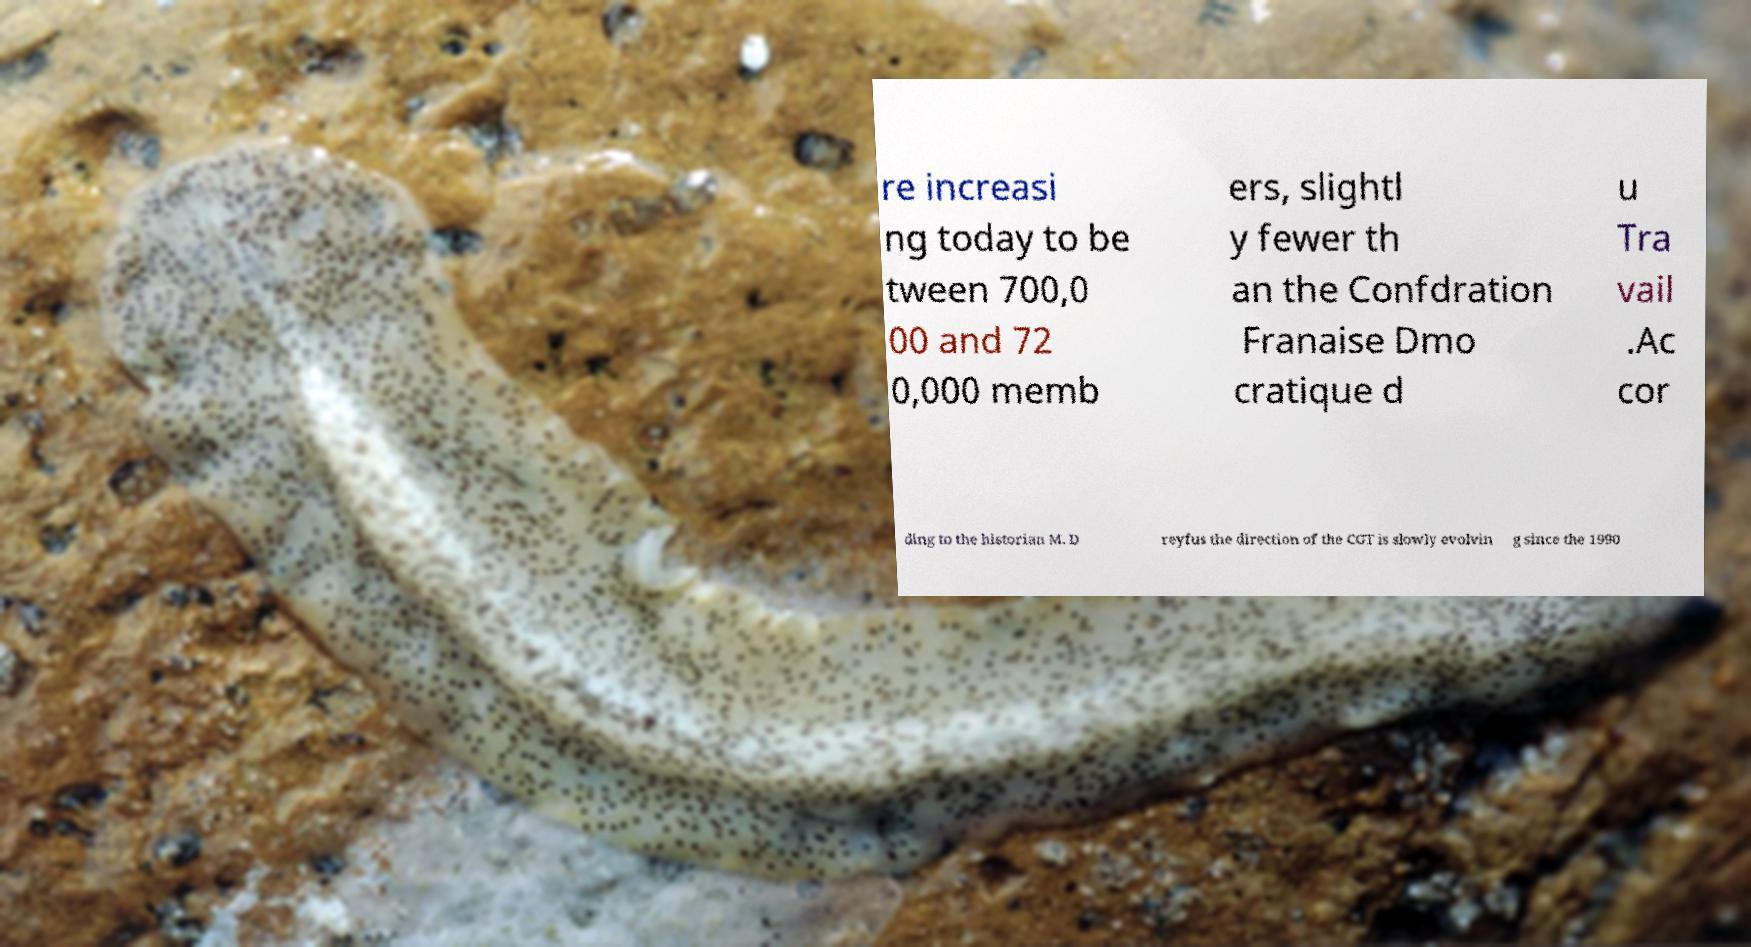Please identify and transcribe the text found in this image. re increasi ng today to be tween 700,0 00 and 72 0,000 memb ers, slightl y fewer th an the Confdration Franaise Dmo cratique d u Tra vail .Ac cor ding to the historian M. D reyfus the direction of the CGT is slowly evolvin g since the 1990 